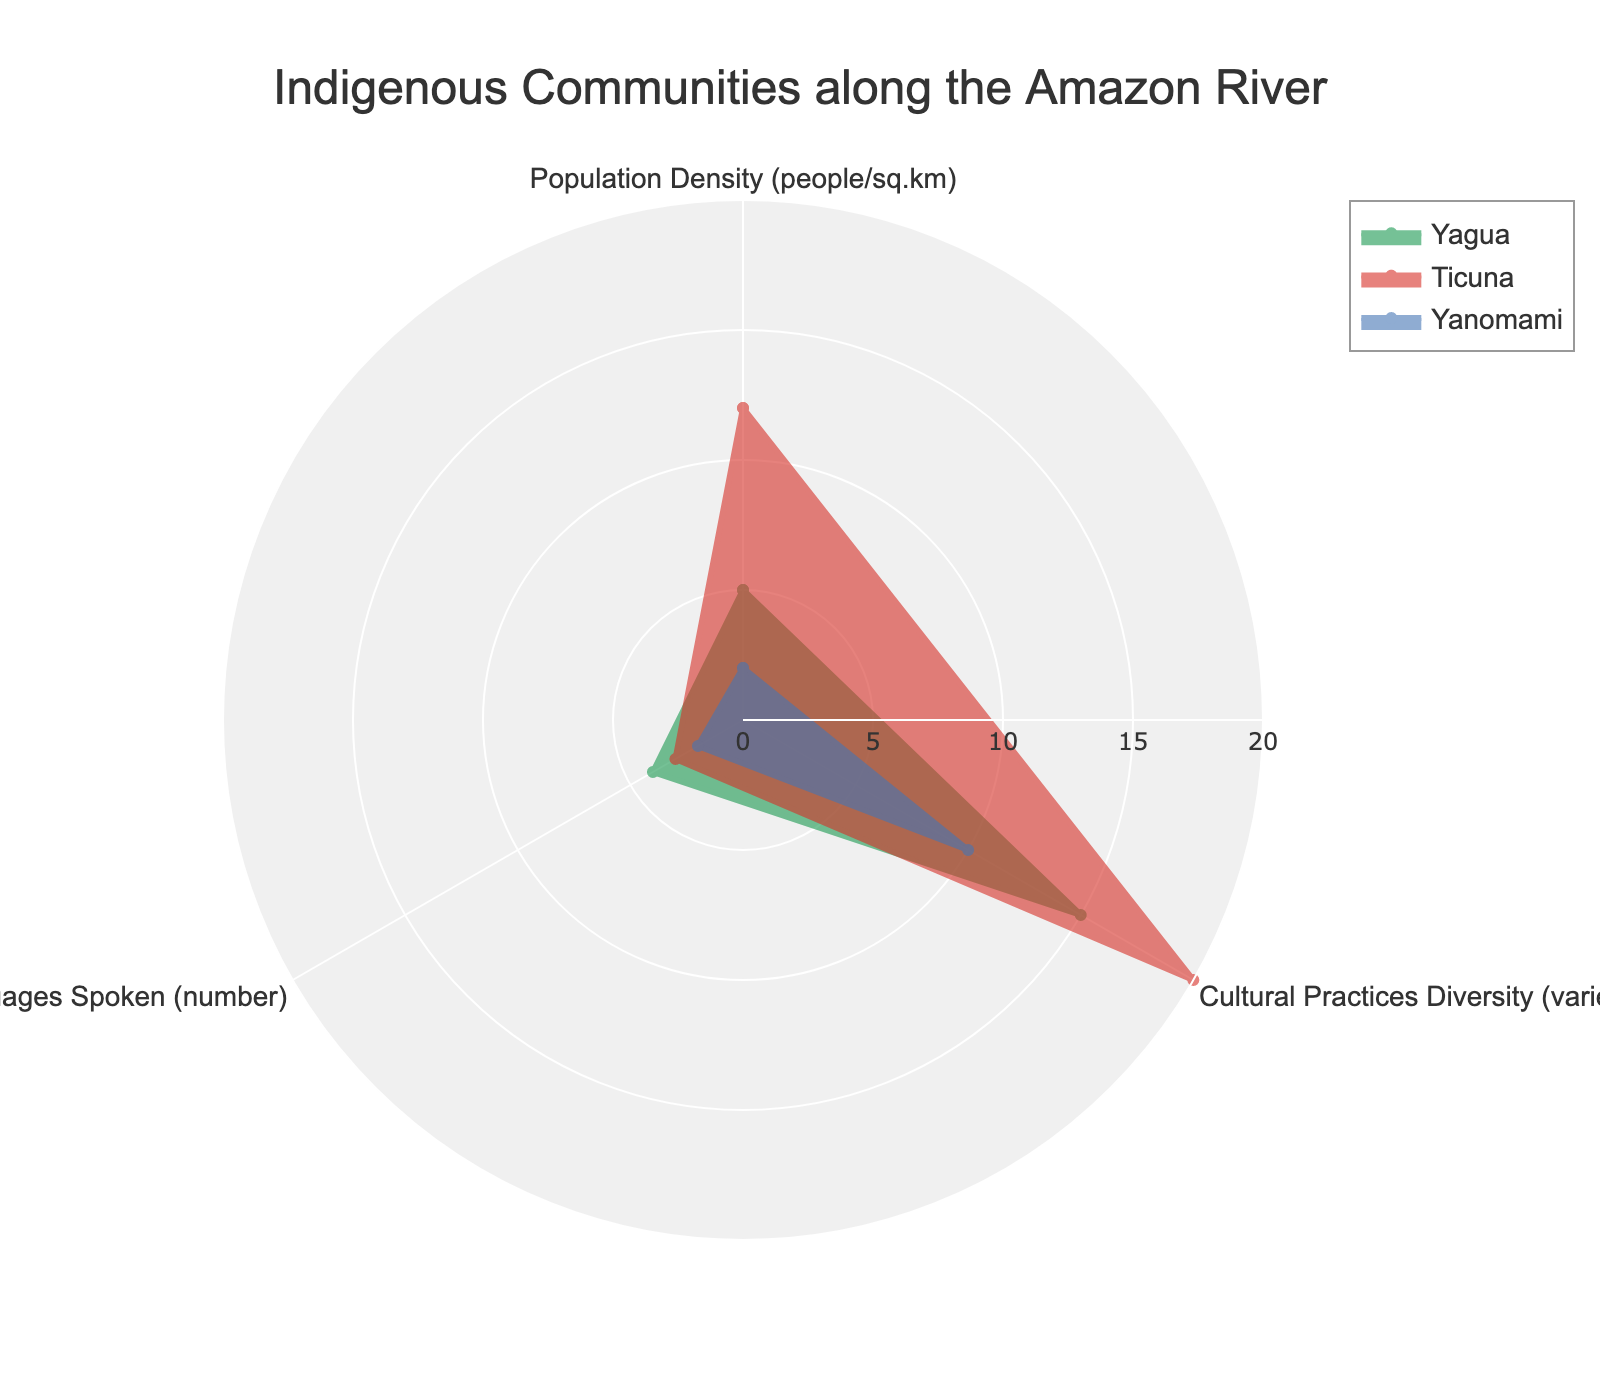What is the title of the chart? The title of the chart is typically located at the top and clearly labeled within the figure. In this case, the title is "Indigenous Communities along the Amazon River".
Answer: Indigenous Communities along the Amazon River How many different cultural practices do the Ticuna have? To find this, you look at the 'Cultural Practices Diversity' axis for the Ticuna group. On this axis, Ticuna reaches the 20 mark.
Answer: 20 Which group has the highest population density? To determine this, you compare the 'Population Density' values for all groups. The Ticuna group has the highest value, reaching 12 people per square kilometer.
Answer: Ticuna What is the range of values for the radial axis? The range is determined by the chart's radial axis settings. Here, it is set from 0 to the maximum value found in the data, which is 20.
Answer: 0 to 20 Which group has the least number of languages spoken? Comparing the 'Languages Spoken' for each group, the Yanomami group has the least with 2 languages spoken.
Answer: Yanomami What is the total number of languages spoken by all three groups combined? Sum the values of 'Languages Spoken' for each group: Yagua (4) + Ticuna (3) + Yanomami (2). This totals to 9.
Answer: 9 Does any group have a balance among all three categories (Population Density, Cultural Practices, Languages Spoken)? For a balanced presence, the values of a group across all categories should be close to each other. The Yagua group has somewhat balanced values: 5 (Population Density), 15 (Cultural Practices), and 4 (Languages Spoken).
Answer: Yagua Which two groups have the biggest difference in the number of cultural practices? Calculate the difference in 'Cultural Practices Diversity' between each pair of groups. The Ticuna (20) and Yanomami (10) have the biggest difference, which is 10.
Answer: Ticuna and Yanomami How do the Yagua and Yanomami compare in terms of population density and number of languages spoken? Compare the values for 'Population Density' and 'Languages Spoken' for both groups: Yagua (5, 4) vs. Yanomami (2, 2). Yagua has a higher population density and more languages spoken.
Answer: Yagua has higher values in both categories Which category (Population Density, Cultural Practices, Languages Spoken) shows the most variability among the groups? Variability can be assessed by examining the range of values: 'Population Density' (2-12), 'Cultural Practices' (10-20), 'Languages Spoken' (2-4). 'Cultural Practices' shows the greatest variability, with a range of 10.
Answer: Cultural Practices 